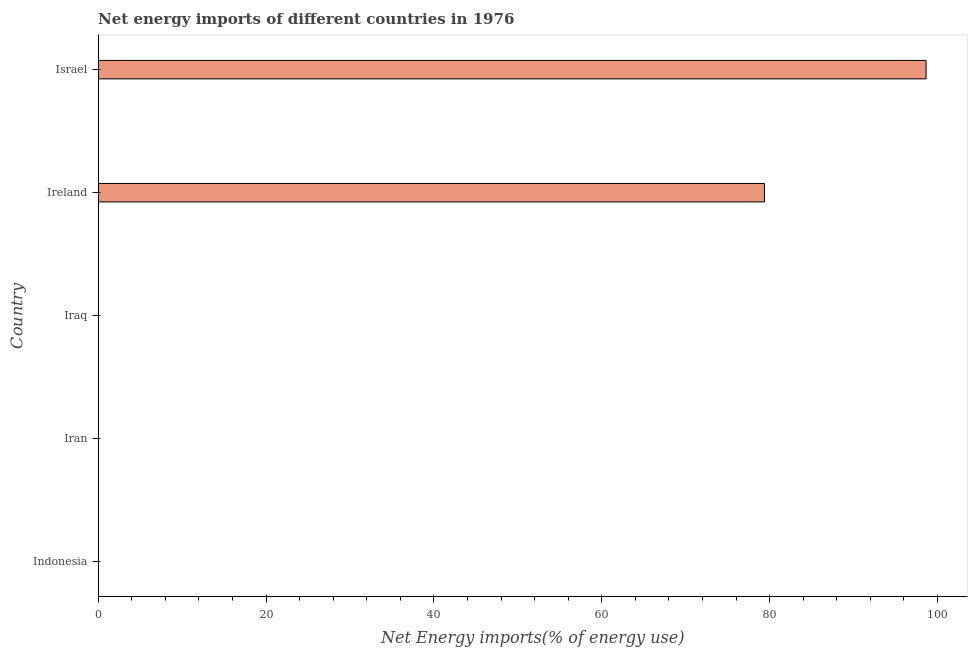Does the graph contain any zero values?
Offer a terse response. Yes. Does the graph contain grids?
Your response must be concise. No. What is the title of the graph?
Keep it short and to the point. Net energy imports of different countries in 1976. What is the label or title of the X-axis?
Keep it short and to the point. Net Energy imports(% of energy use). Across all countries, what is the maximum energy imports?
Keep it short and to the point. 98.64. Across all countries, what is the minimum energy imports?
Offer a very short reply. 0. In which country was the energy imports maximum?
Your response must be concise. Israel. What is the sum of the energy imports?
Offer a terse response. 178.02. What is the difference between the energy imports in Ireland and Israel?
Your response must be concise. -19.26. What is the average energy imports per country?
Provide a succinct answer. 35.6. In how many countries, is the energy imports greater than 8 %?
Ensure brevity in your answer.  2. What is the ratio of the energy imports in Ireland to that in Israel?
Keep it short and to the point. 0.81. What is the difference between the highest and the lowest energy imports?
Give a very brief answer. 98.64. In how many countries, is the energy imports greater than the average energy imports taken over all countries?
Make the answer very short. 2. How many bars are there?
Your answer should be very brief. 2. Are all the bars in the graph horizontal?
Your answer should be very brief. Yes. How many countries are there in the graph?
Your response must be concise. 5. What is the difference between two consecutive major ticks on the X-axis?
Your answer should be compact. 20. Are the values on the major ticks of X-axis written in scientific E-notation?
Your response must be concise. No. What is the Net Energy imports(% of energy use) of Iran?
Your response must be concise. 0. What is the Net Energy imports(% of energy use) of Ireland?
Keep it short and to the point. 79.38. What is the Net Energy imports(% of energy use) in Israel?
Ensure brevity in your answer.  98.64. What is the difference between the Net Energy imports(% of energy use) in Ireland and Israel?
Ensure brevity in your answer.  -19.26. What is the ratio of the Net Energy imports(% of energy use) in Ireland to that in Israel?
Your response must be concise. 0.81. 